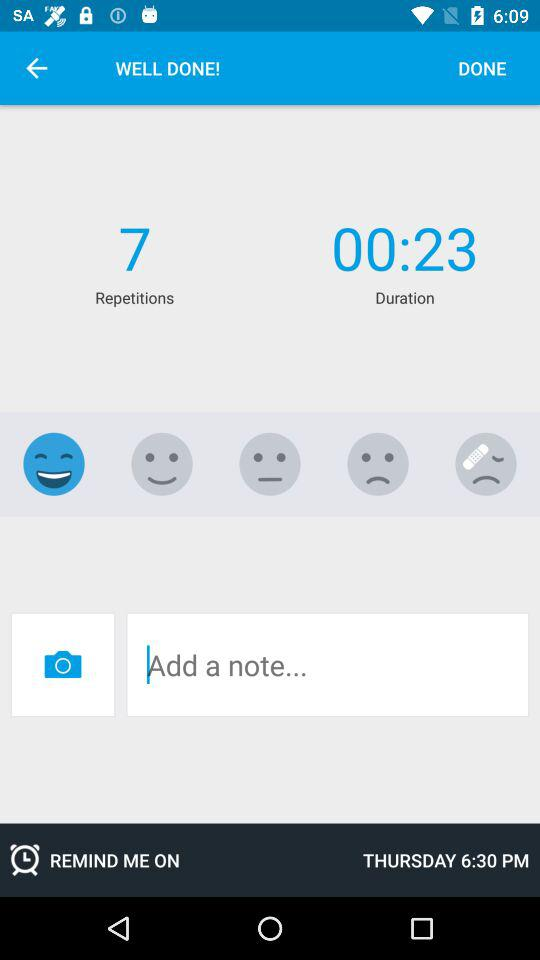What time is set as a reminder? The time set as a reminder is 6:30 p.m. 